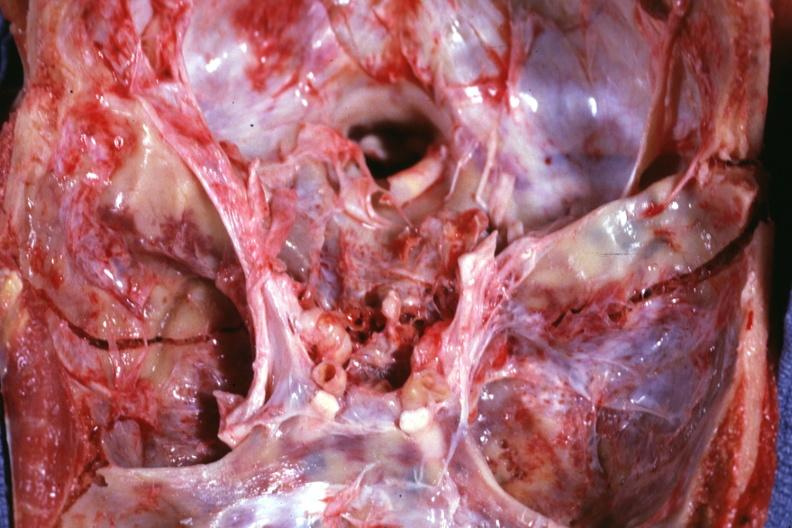what is present?
Answer the question using a single word or phrase. Basilar skull fracture 